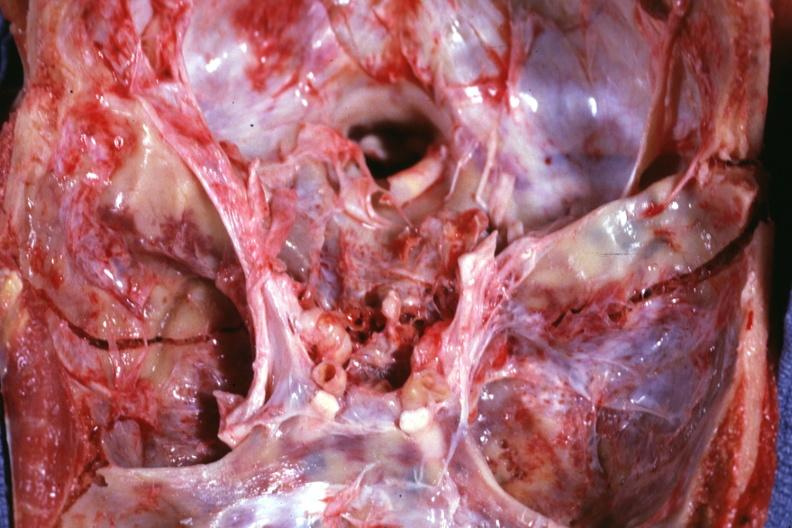what is present?
Answer the question using a single word or phrase. Basilar skull fracture 